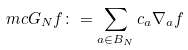<formula> <loc_0><loc_0><loc_500><loc_500>\ m c G _ { N } f \colon = \sum _ { a \in B _ { N } } c _ { a } \nabla _ { a } f</formula> 